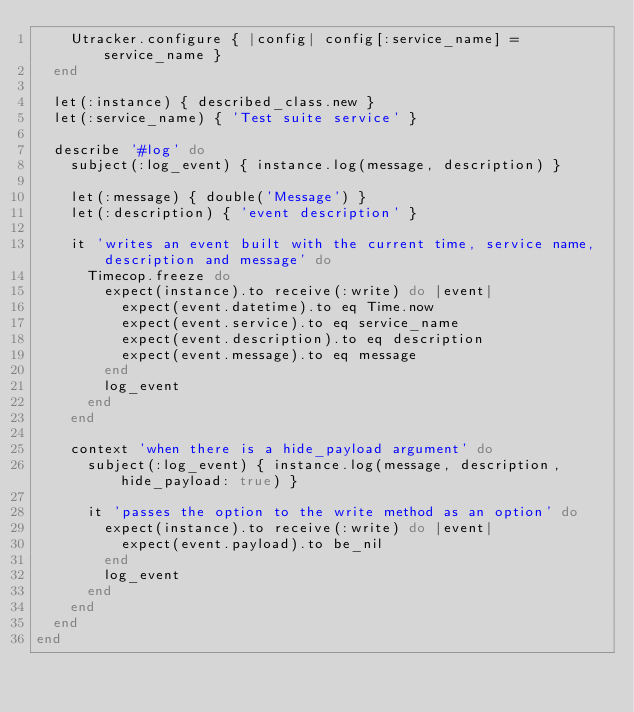Convert code to text. <code><loc_0><loc_0><loc_500><loc_500><_Ruby_>    Utracker.configure { |config| config[:service_name] = service_name }
  end

  let(:instance) { described_class.new }
  let(:service_name) { 'Test suite service' }

  describe '#log' do
    subject(:log_event) { instance.log(message, description) }

    let(:message) { double('Message') }
    let(:description) { 'event description' }

    it 'writes an event built with the current time, service name, description and message' do
      Timecop.freeze do
        expect(instance).to receive(:write) do |event|
          expect(event.datetime).to eq Time.now
          expect(event.service).to eq service_name
          expect(event.description).to eq description
          expect(event.message).to eq message
        end
        log_event
      end
    end

    context 'when there is a hide_payload argument' do
      subject(:log_event) { instance.log(message, description, hide_payload: true) }

      it 'passes the option to the write method as an option' do
        expect(instance).to receive(:write) do |event|
          expect(event.payload).to be_nil
        end
        log_event
      end
    end
  end
end
</code> 